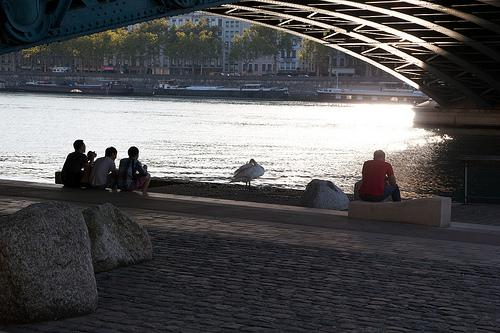Question: how many men sitting by the river?
Choices:
A. Three.
B. Two.
C. Four.
D. Five.
Answer with the letter. Answer: C Question: what is the color of the man's shirt on right?
Choices:
A. Red.
B. Blue.
C. White.
D. Black.
Answer with the letter. Answer: A Question: why the men are sitting by the river?
Choices:
A. Playing.
B. Relaxing.
C. Boating.
D. Fishing.
Answer with the letter. Answer: B Question: who are sitting by the sidewalk?
Choices:
A. Women.
B. Children.
C. Men.
D. The group of students.
Answer with the letter. Answer: C 